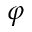Convert formula to latex. <formula><loc_0><loc_0><loc_500><loc_500>\varphi</formula> 